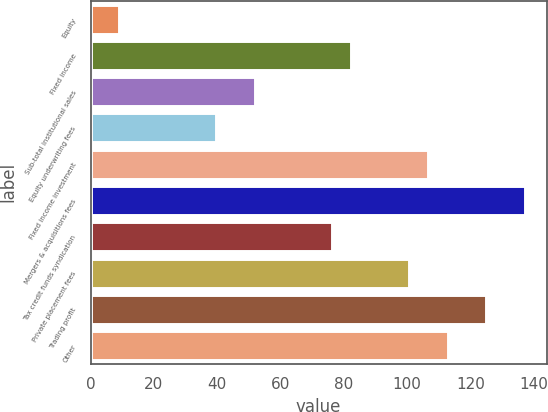Convert chart to OTSL. <chart><loc_0><loc_0><loc_500><loc_500><bar_chart><fcel>Equity<fcel>Fixed income<fcel>Sub-total institutional sales<fcel>Equity underwriting fees<fcel>Fixed income investment<fcel>Mergers & acquisitions fees<fcel>Tax credit funds syndication<fcel>Private placement fees<fcel>Trading profit<fcel>Other<nl><fcel>9.1<fcel>82.3<fcel>51.8<fcel>39.6<fcel>106.7<fcel>137.2<fcel>76.2<fcel>100.6<fcel>125<fcel>112.8<nl></chart> 